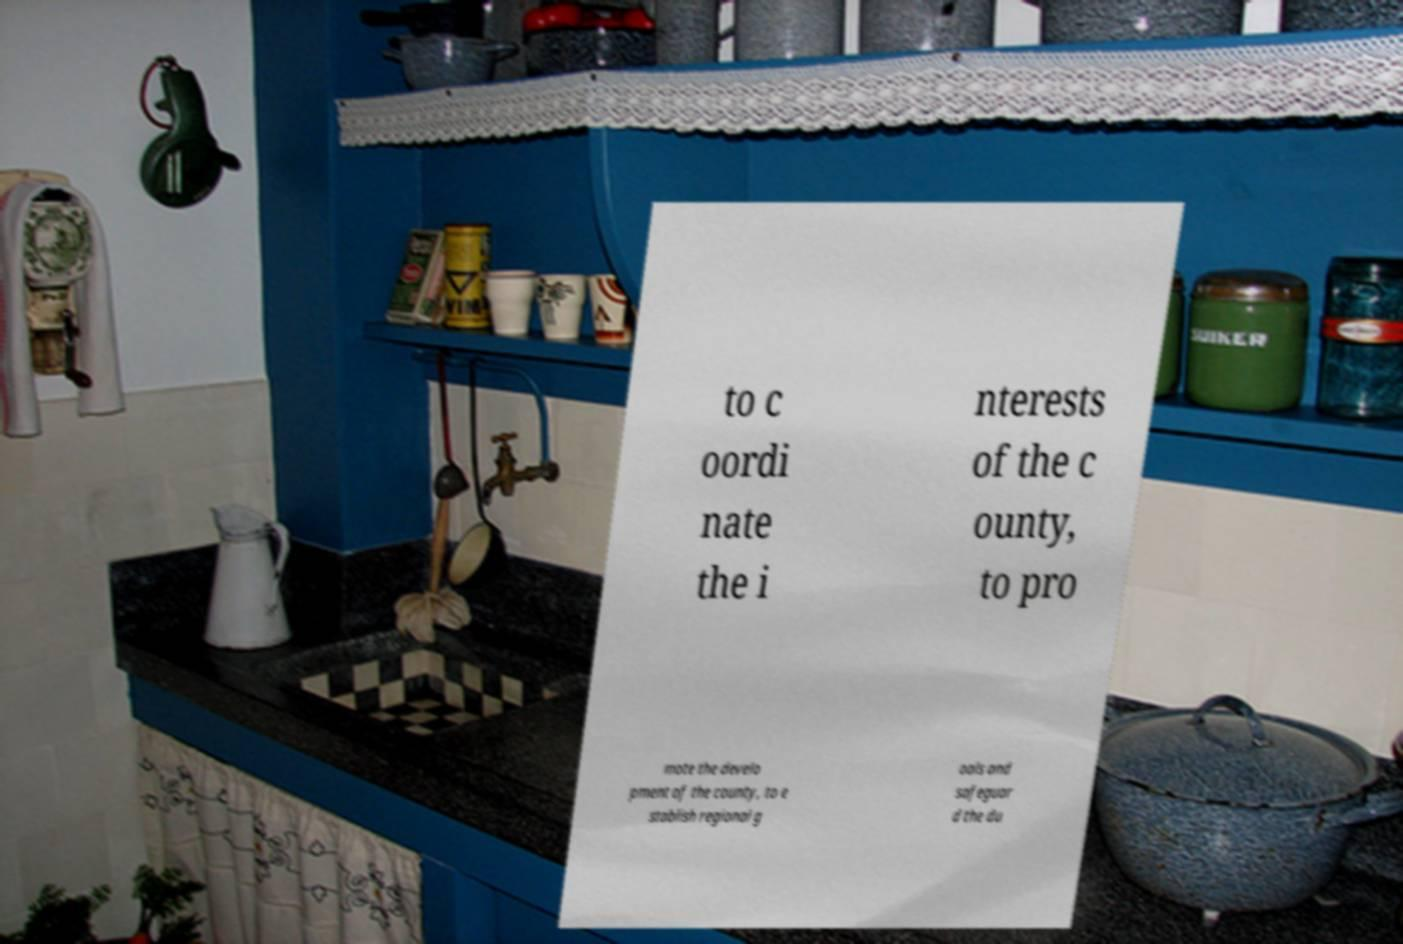For documentation purposes, I need the text within this image transcribed. Could you provide that? to c oordi nate the i nterests of the c ounty, to pro mote the develo pment of the county, to e stablish regional g oals and safeguar d the du 